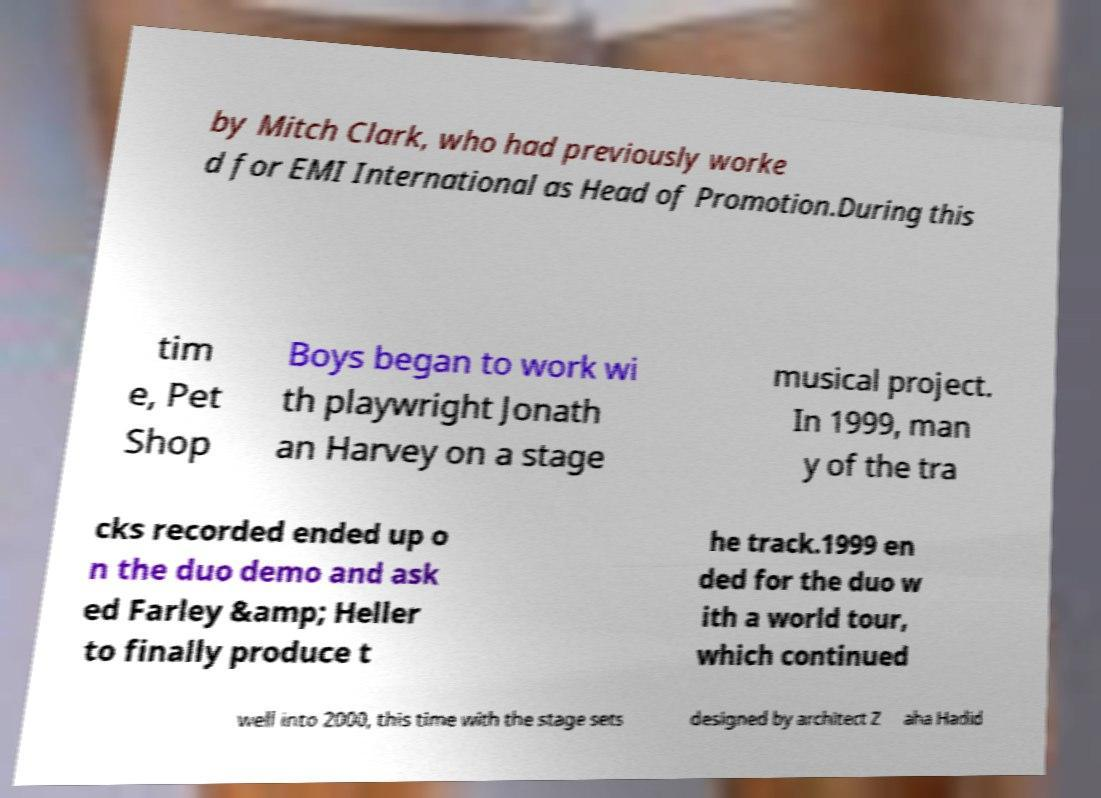Please identify and transcribe the text found in this image. by Mitch Clark, who had previously worke d for EMI International as Head of Promotion.During this tim e, Pet Shop Boys began to work wi th playwright Jonath an Harvey on a stage musical project. In 1999, man y of the tra cks recorded ended up o n the duo demo and ask ed Farley &amp; Heller to finally produce t he track.1999 en ded for the duo w ith a world tour, which continued well into 2000, this time with the stage sets designed by architect Z aha Hadid 